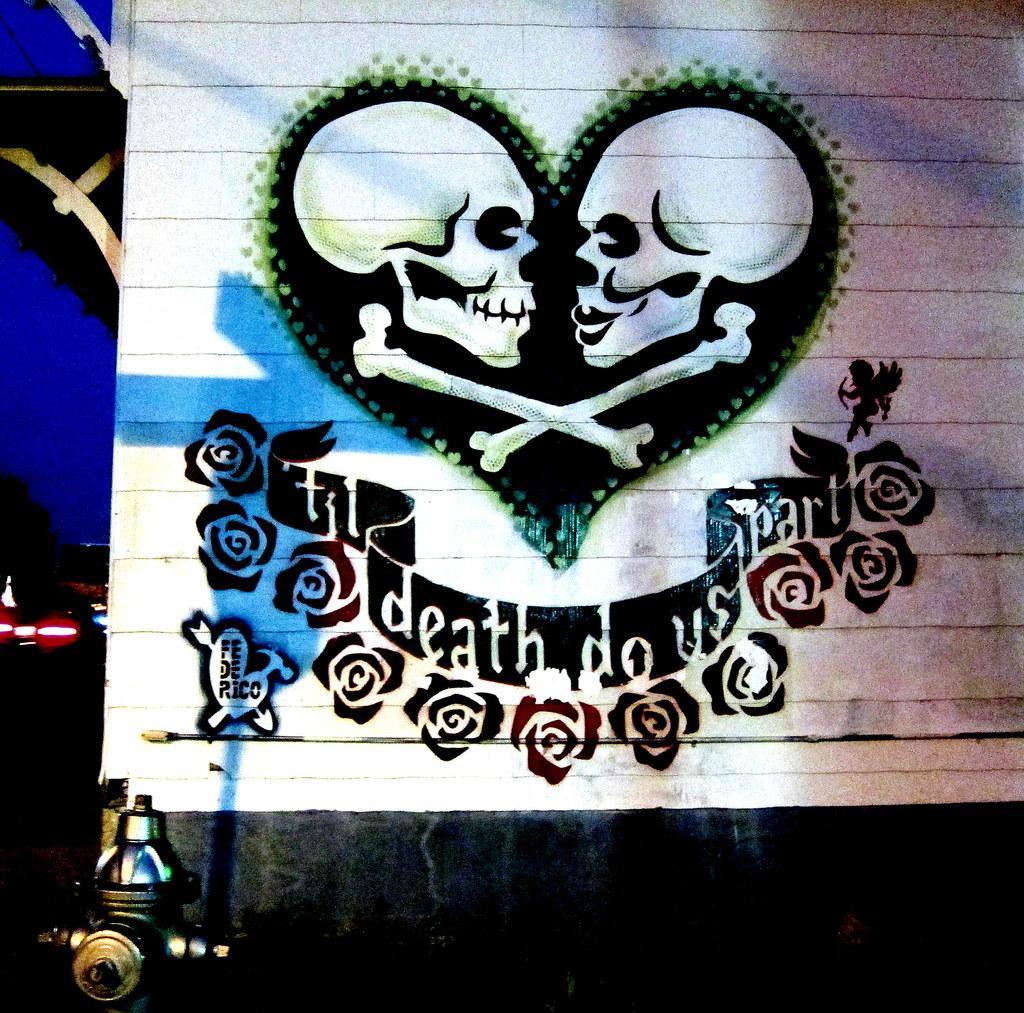Please provide a concise description of this image. In the image there is a white poster. Inside the poster there is a heart symbol with two skulls and bones. Below that there is a design with flowers and also there are few words. And to the bottom left corner of the image there is a standpipe. And to the left corner of the image there are blue paintings on the walls. 